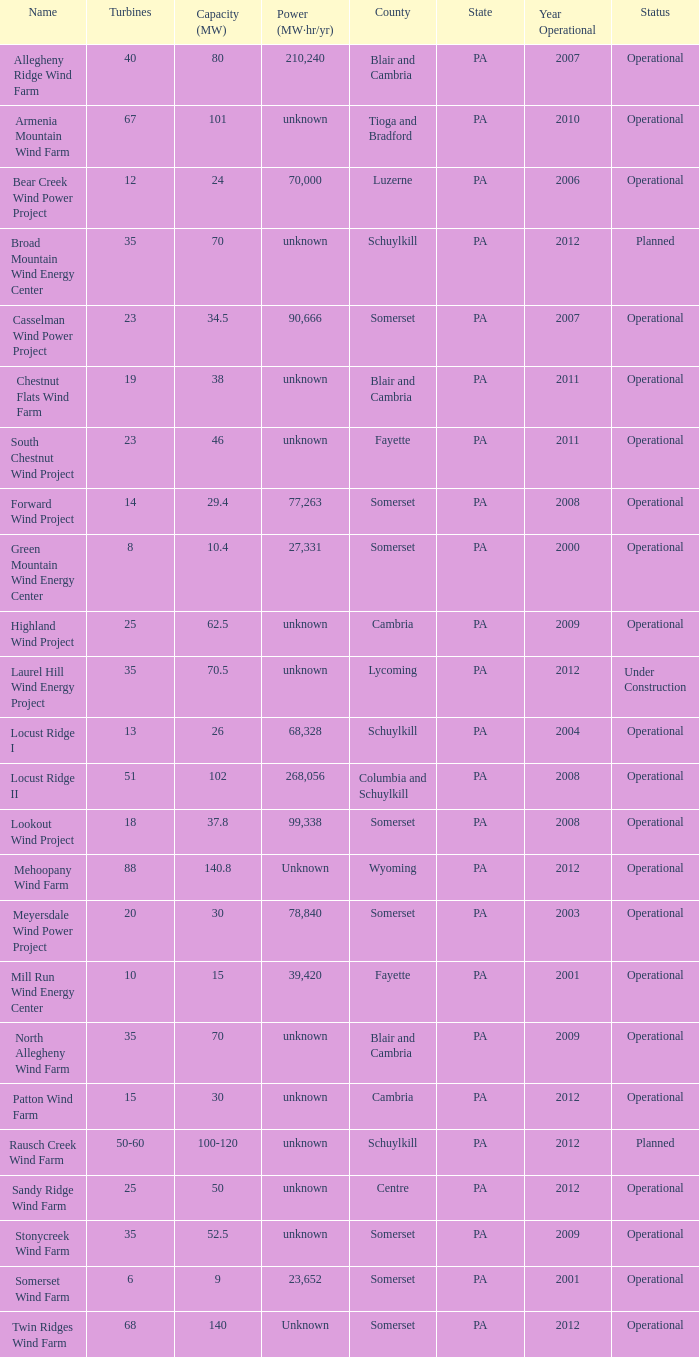Can you identify a farm that is operational and has a capacity of 70? North Allegheny Wind Farm. 